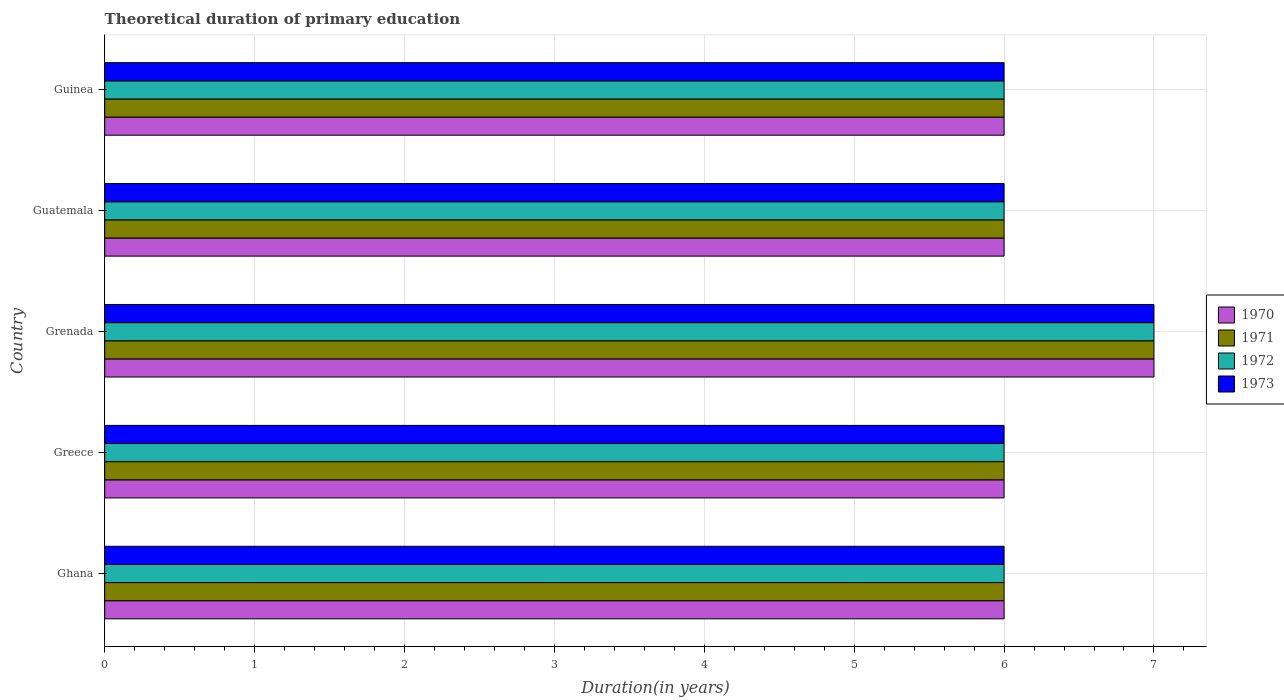How many different coloured bars are there?
Make the answer very short. 4. How many groups of bars are there?
Your answer should be compact. 5. Are the number of bars per tick equal to the number of legend labels?
Ensure brevity in your answer.  Yes. What is the label of the 2nd group of bars from the top?
Keep it short and to the point. Guatemala. In how many cases, is the number of bars for a given country not equal to the number of legend labels?
Provide a succinct answer. 0. What is the total theoretical duration of primary education in 1970 in Grenada?
Ensure brevity in your answer.  7. In which country was the total theoretical duration of primary education in 1970 maximum?
Provide a short and direct response. Grenada. What is the total total theoretical duration of primary education in 1973 in the graph?
Provide a short and direct response. 31. What is the difference between the total theoretical duration of primary education in 1970 in Guinea and the total theoretical duration of primary education in 1971 in Guatemala?
Your response must be concise. 0. What is the average total theoretical duration of primary education in 1972 per country?
Offer a terse response. 6.2. What is the difference between the total theoretical duration of primary education in 1971 and total theoretical duration of primary education in 1972 in Greece?
Provide a short and direct response. 0. In how many countries, is the total theoretical duration of primary education in 1972 greater than 1.2 years?
Your answer should be very brief. 5. What is the ratio of the total theoretical duration of primary education in 1972 in Ghana to that in Guatemala?
Your answer should be very brief. 1. What is the difference between the highest and the second highest total theoretical duration of primary education in 1971?
Offer a terse response. 1. What is the difference between the highest and the lowest total theoretical duration of primary education in 1971?
Your answer should be very brief. 1. In how many countries, is the total theoretical duration of primary education in 1971 greater than the average total theoretical duration of primary education in 1971 taken over all countries?
Keep it short and to the point. 1. What does the 1st bar from the bottom in Guatemala represents?
Provide a short and direct response. 1970. Does the graph contain grids?
Your answer should be compact. Yes. How many legend labels are there?
Your response must be concise. 4. How are the legend labels stacked?
Your answer should be compact. Vertical. What is the title of the graph?
Give a very brief answer. Theoretical duration of primary education. Does "1968" appear as one of the legend labels in the graph?
Keep it short and to the point. No. What is the label or title of the X-axis?
Make the answer very short. Duration(in years). What is the label or title of the Y-axis?
Keep it short and to the point. Country. What is the Duration(in years) of 1970 in Ghana?
Make the answer very short. 6. What is the Duration(in years) of 1971 in Ghana?
Your response must be concise. 6. What is the Duration(in years) of 1972 in Ghana?
Provide a succinct answer. 6. What is the Duration(in years) in 1973 in Ghana?
Your answer should be compact. 6. What is the Duration(in years) in 1973 in Greece?
Your answer should be compact. 6. What is the Duration(in years) in 1971 in Grenada?
Your response must be concise. 7. What is the Duration(in years) of 1972 in Grenada?
Provide a succinct answer. 7. What is the Duration(in years) in 1970 in Guatemala?
Your response must be concise. 6. What is the Duration(in years) of 1971 in Guatemala?
Ensure brevity in your answer.  6. What is the Duration(in years) of 1970 in Guinea?
Give a very brief answer. 6. What is the Duration(in years) in 1973 in Guinea?
Provide a short and direct response. 6. Across all countries, what is the maximum Duration(in years) in 1971?
Offer a terse response. 7. Across all countries, what is the minimum Duration(in years) of 1970?
Your answer should be very brief. 6. Across all countries, what is the minimum Duration(in years) of 1971?
Provide a succinct answer. 6. Across all countries, what is the minimum Duration(in years) of 1972?
Give a very brief answer. 6. Across all countries, what is the minimum Duration(in years) in 1973?
Offer a terse response. 6. What is the total Duration(in years) in 1970 in the graph?
Provide a succinct answer. 31. What is the total Duration(in years) in 1972 in the graph?
Offer a terse response. 31. What is the difference between the Duration(in years) in 1970 in Ghana and that in Greece?
Offer a very short reply. 0. What is the difference between the Duration(in years) in 1971 in Ghana and that in Greece?
Provide a succinct answer. 0. What is the difference between the Duration(in years) of 1972 in Ghana and that in Greece?
Your response must be concise. 0. What is the difference between the Duration(in years) in 1970 in Ghana and that in Grenada?
Give a very brief answer. -1. What is the difference between the Duration(in years) in 1971 in Ghana and that in Grenada?
Your answer should be very brief. -1. What is the difference between the Duration(in years) in 1973 in Ghana and that in Guatemala?
Give a very brief answer. 0. What is the difference between the Duration(in years) in 1970 in Ghana and that in Guinea?
Your answer should be compact. 0. What is the difference between the Duration(in years) of 1971 in Ghana and that in Guinea?
Your answer should be compact. 0. What is the difference between the Duration(in years) in 1970 in Greece and that in Grenada?
Your answer should be compact. -1. What is the difference between the Duration(in years) of 1972 in Greece and that in Grenada?
Your answer should be very brief. -1. What is the difference between the Duration(in years) of 1970 in Greece and that in Guatemala?
Provide a succinct answer. 0. What is the difference between the Duration(in years) in 1971 in Greece and that in Guatemala?
Offer a very short reply. 0. What is the difference between the Duration(in years) of 1972 in Greece and that in Guatemala?
Your response must be concise. 0. What is the difference between the Duration(in years) in 1973 in Greece and that in Guatemala?
Offer a very short reply. 0. What is the difference between the Duration(in years) in 1971 in Grenada and that in Guatemala?
Your answer should be very brief. 1. What is the difference between the Duration(in years) in 1973 in Grenada and that in Guatemala?
Make the answer very short. 1. What is the difference between the Duration(in years) of 1971 in Grenada and that in Guinea?
Offer a terse response. 1. What is the difference between the Duration(in years) of 1972 in Grenada and that in Guinea?
Offer a terse response. 1. What is the difference between the Duration(in years) of 1970 in Guatemala and that in Guinea?
Offer a terse response. 0. What is the difference between the Duration(in years) in 1972 in Guatemala and that in Guinea?
Provide a succinct answer. 0. What is the difference between the Duration(in years) in 1973 in Guatemala and that in Guinea?
Ensure brevity in your answer.  0. What is the difference between the Duration(in years) in 1970 in Ghana and the Duration(in years) in 1971 in Greece?
Make the answer very short. 0. What is the difference between the Duration(in years) in 1970 in Ghana and the Duration(in years) in 1971 in Grenada?
Provide a short and direct response. -1. What is the difference between the Duration(in years) of 1970 in Ghana and the Duration(in years) of 1972 in Grenada?
Ensure brevity in your answer.  -1. What is the difference between the Duration(in years) of 1970 in Ghana and the Duration(in years) of 1973 in Grenada?
Give a very brief answer. -1. What is the difference between the Duration(in years) of 1971 in Ghana and the Duration(in years) of 1973 in Grenada?
Offer a terse response. -1. What is the difference between the Duration(in years) of 1970 in Ghana and the Duration(in years) of 1971 in Guatemala?
Provide a succinct answer. 0. What is the difference between the Duration(in years) of 1970 in Ghana and the Duration(in years) of 1972 in Guatemala?
Offer a terse response. 0. What is the difference between the Duration(in years) in 1970 in Ghana and the Duration(in years) in 1973 in Guatemala?
Offer a terse response. 0. What is the difference between the Duration(in years) in 1972 in Ghana and the Duration(in years) in 1973 in Guatemala?
Offer a terse response. 0. What is the difference between the Duration(in years) in 1970 in Ghana and the Duration(in years) in 1971 in Guinea?
Ensure brevity in your answer.  0. What is the difference between the Duration(in years) in 1971 in Ghana and the Duration(in years) in 1972 in Guinea?
Give a very brief answer. 0. What is the difference between the Duration(in years) of 1972 in Ghana and the Duration(in years) of 1973 in Guinea?
Provide a short and direct response. 0. What is the difference between the Duration(in years) in 1970 in Greece and the Duration(in years) in 1971 in Grenada?
Offer a terse response. -1. What is the difference between the Duration(in years) of 1970 in Greece and the Duration(in years) of 1972 in Grenada?
Provide a short and direct response. -1. What is the difference between the Duration(in years) of 1971 in Greece and the Duration(in years) of 1973 in Grenada?
Your answer should be very brief. -1. What is the difference between the Duration(in years) in 1972 in Greece and the Duration(in years) in 1973 in Grenada?
Give a very brief answer. -1. What is the difference between the Duration(in years) in 1970 in Greece and the Duration(in years) in 1971 in Guatemala?
Your answer should be compact. 0. What is the difference between the Duration(in years) of 1970 in Greece and the Duration(in years) of 1973 in Guatemala?
Keep it short and to the point. 0. What is the difference between the Duration(in years) in 1971 in Greece and the Duration(in years) in 1973 in Guatemala?
Make the answer very short. 0. What is the difference between the Duration(in years) in 1972 in Greece and the Duration(in years) in 1973 in Guatemala?
Keep it short and to the point. 0. What is the difference between the Duration(in years) in 1971 in Greece and the Duration(in years) in 1972 in Guinea?
Keep it short and to the point. 0. What is the difference between the Duration(in years) of 1971 in Greece and the Duration(in years) of 1973 in Guinea?
Keep it short and to the point. 0. What is the difference between the Duration(in years) in 1972 in Greece and the Duration(in years) in 1973 in Guinea?
Ensure brevity in your answer.  0. What is the difference between the Duration(in years) in 1970 in Grenada and the Duration(in years) in 1973 in Guatemala?
Your answer should be very brief. 1. What is the difference between the Duration(in years) of 1971 in Grenada and the Duration(in years) of 1972 in Guatemala?
Provide a succinct answer. 1. What is the difference between the Duration(in years) of 1970 in Grenada and the Duration(in years) of 1971 in Guinea?
Offer a terse response. 1. What is the difference between the Duration(in years) in 1970 in Grenada and the Duration(in years) in 1972 in Guinea?
Give a very brief answer. 1. What is the difference between the Duration(in years) in 1970 in Grenada and the Duration(in years) in 1973 in Guinea?
Your response must be concise. 1. What is the difference between the Duration(in years) of 1971 in Grenada and the Duration(in years) of 1973 in Guinea?
Provide a short and direct response. 1. What is the difference between the Duration(in years) of 1972 in Grenada and the Duration(in years) of 1973 in Guinea?
Make the answer very short. 1. What is the difference between the Duration(in years) of 1970 in Guatemala and the Duration(in years) of 1971 in Guinea?
Provide a succinct answer. 0. What is the difference between the Duration(in years) of 1970 in Guatemala and the Duration(in years) of 1972 in Guinea?
Provide a short and direct response. 0. What is the difference between the Duration(in years) in 1971 in Guatemala and the Duration(in years) in 1972 in Guinea?
Your answer should be very brief. 0. What is the difference between the Duration(in years) in 1971 in Guatemala and the Duration(in years) in 1973 in Guinea?
Keep it short and to the point. 0. What is the average Duration(in years) of 1971 per country?
Provide a short and direct response. 6.2. What is the difference between the Duration(in years) of 1970 and Duration(in years) of 1971 in Ghana?
Your answer should be compact. 0. What is the difference between the Duration(in years) of 1970 and Duration(in years) of 1973 in Ghana?
Keep it short and to the point. 0. What is the difference between the Duration(in years) in 1971 and Duration(in years) in 1972 in Ghana?
Give a very brief answer. 0. What is the difference between the Duration(in years) in 1971 and Duration(in years) in 1973 in Ghana?
Keep it short and to the point. 0. What is the difference between the Duration(in years) in 1972 and Duration(in years) in 1973 in Ghana?
Your answer should be very brief. 0. What is the difference between the Duration(in years) of 1970 and Duration(in years) of 1971 in Greece?
Give a very brief answer. 0. What is the difference between the Duration(in years) of 1970 and Duration(in years) of 1972 in Greece?
Give a very brief answer. 0. What is the difference between the Duration(in years) in 1970 and Duration(in years) in 1973 in Greece?
Keep it short and to the point. 0. What is the difference between the Duration(in years) of 1971 and Duration(in years) of 1972 in Greece?
Your answer should be very brief. 0. What is the difference between the Duration(in years) of 1971 and Duration(in years) of 1973 in Greece?
Ensure brevity in your answer.  0. What is the difference between the Duration(in years) of 1971 and Duration(in years) of 1973 in Grenada?
Make the answer very short. 0. What is the difference between the Duration(in years) of 1970 and Duration(in years) of 1973 in Guatemala?
Your answer should be compact. 0. What is the difference between the Duration(in years) in 1970 and Duration(in years) in 1972 in Guinea?
Give a very brief answer. 0. What is the difference between the Duration(in years) of 1972 and Duration(in years) of 1973 in Guinea?
Make the answer very short. 0. What is the ratio of the Duration(in years) in 1970 in Ghana to that in Greece?
Ensure brevity in your answer.  1. What is the ratio of the Duration(in years) in 1971 in Ghana to that in Greece?
Offer a very short reply. 1. What is the ratio of the Duration(in years) of 1972 in Ghana to that in Greece?
Your answer should be compact. 1. What is the ratio of the Duration(in years) of 1973 in Ghana to that in Grenada?
Your response must be concise. 0.86. What is the ratio of the Duration(in years) of 1972 in Ghana to that in Guatemala?
Offer a very short reply. 1. What is the ratio of the Duration(in years) in 1973 in Ghana to that in Guatemala?
Provide a short and direct response. 1. What is the ratio of the Duration(in years) in 1970 in Greece to that in Grenada?
Offer a very short reply. 0.86. What is the ratio of the Duration(in years) of 1971 in Greece to that in Grenada?
Your answer should be compact. 0.86. What is the ratio of the Duration(in years) of 1972 in Greece to that in Grenada?
Make the answer very short. 0.86. What is the ratio of the Duration(in years) in 1973 in Greece to that in Grenada?
Offer a terse response. 0.86. What is the ratio of the Duration(in years) in 1973 in Greece to that in Guatemala?
Provide a succinct answer. 1. What is the ratio of the Duration(in years) of 1970 in Grenada to that in Guinea?
Ensure brevity in your answer.  1.17. What is the ratio of the Duration(in years) in 1971 in Grenada to that in Guinea?
Give a very brief answer. 1.17. What is the ratio of the Duration(in years) in 1972 in Grenada to that in Guinea?
Your response must be concise. 1.17. What is the ratio of the Duration(in years) in 1970 in Guatemala to that in Guinea?
Your response must be concise. 1. What is the ratio of the Duration(in years) in 1972 in Guatemala to that in Guinea?
Offer a terse response. 1. What is the difference between the highest and the second highest Duration(in years) in 1970?
Your answer should be compact. 1. What is the difference between the highest and the second highest Duration(in years) in 1972?
Offer a terse response. 1. What is the difference between the highest and the lowest Duration(in years) in 1970?
Your response must be concise. 1. What is the difference between the highest and the lowest Duration(in years) in 1971?
Offer a very short reply. 1. What is the difference between the highest and the lowest Duration(in years) in 1972?
Your answer should be compact. 1. 